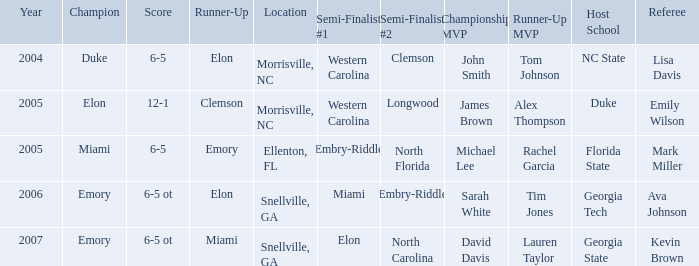Where did the last match occur in 2007? Snellville, GA. 